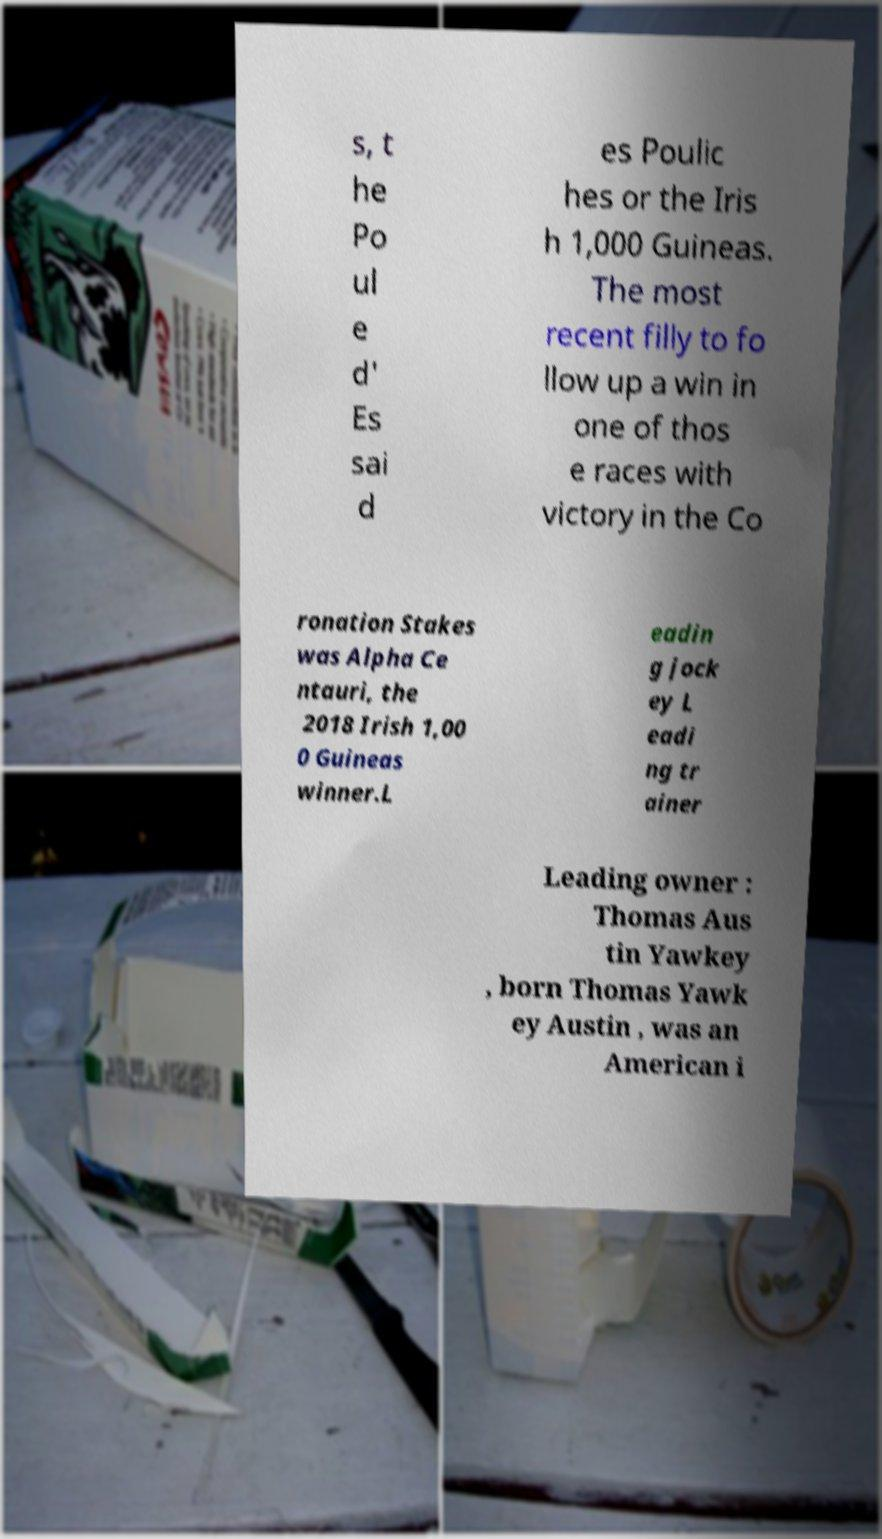Please read and relay the text visible in this image. What does it say? s, t he Po ul e d' Es sai d es Poulic hes or the Iris h 1,000 Guineas. The most recent filly to fo llow up a win in one of thos e races with victory in the Co ronation Stakes was Alpha Ce ntauri, the 2018 Irish 1,00 0 Guineas winner.L eadin g jock ey L eadi ng tr ainer Leading owner : Thomas Aus tin Yawkey , born Thomas Yawk ey Austin , was an American i 